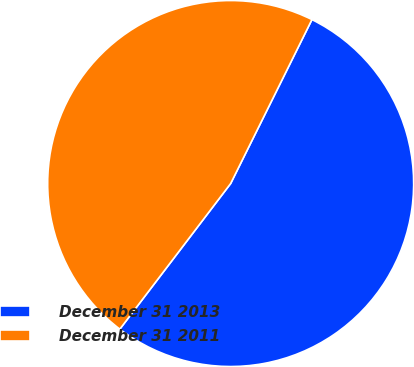Convert chart to OTSL. <chart><loc_0><loc_0><loc_500><loc_500><pie_chart><fcel>December 31 2013<fcel>December 31 2011<nl><fcel>53.03%<fcel>46.97%<nl></chart> 